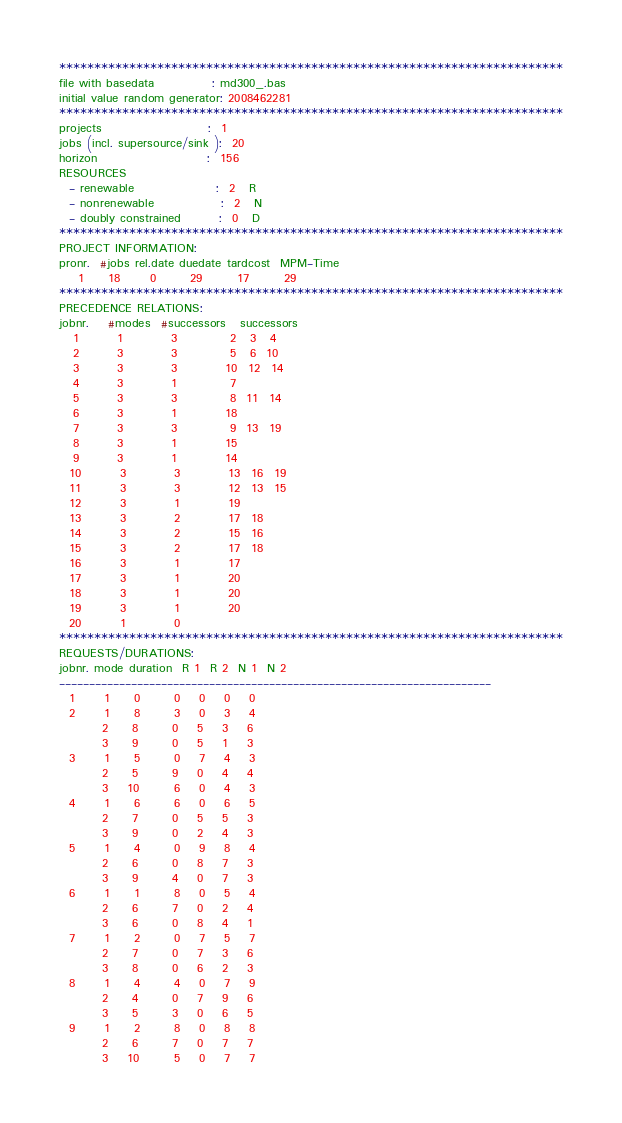Convert code to text. <code><loc_0><loc_0><loc_500><loc_500><_ObjectiveC_>************************************************************************
file with basedata            : md300_.bas
initial value random generator: 2008462281
************************************************************************
projects                      :  1
jobs (incl. supersource/sink ):  20
horizon                       :  156
RESOURCES
  - renewable                 :  2   R
  - nonrenewable              :  2   N
  - doubly constrained        :  0   D
************************************************************************
PROJECT INFORMATION:
pronr.  #jobs rel.date duedate tardcost  MPM-Time
    1     18      0       29       17       29
************************************************************************
PRECEDENCE RELATIONS:
jobnr.    #modes  #successors   successors
   1        1          3           2   3   4
   2        3          3           5   6  10
   3        3          3          10  12  14
   4        3          1           7
   5        3          3           8  11  14
   6        3          1          18
   7        3          3           9  13  19
   8        3          1          15
   9        3          1          14
  10        3          3          13  16  19
  11        3          3          12  13  15
  12        3          1          19
  13        3          2          17  18
  14        3          2          15  16
  15        3          2          17  18
  16        3          1          17
  17        3          1          20
  18        3          1          20
  19        3          1          20
  20        1          0        
************************************************************************
REQUESTS/DURATIONS:
jobnr. mode duration  R 1  R 2  N 1  N 2
------------------------------------------------------------------------
  1      1     0       0    0    0    0
  2      1     8       3    0    3    4
         2     8       0    5    3    6
         3     9       0    5    1    3
  3      1     5       0    7    4    3
         2     5       9    0    4    4
         3    10       6    0    4    3
  4      1     6       6    0    6    5
         2     7       0    5    5    3
         3     9       0    2    4    3
  5      1     4       0    9    8    4
         2     6       0    8    7    3
         3     9       4    0    7    3
  6      1     1       8    0    5    4
         2     6       7    0    2    4
         3     6       0    8    4    1
  7      1     2       0    7    5    7
         2     7       0    7    3    6
         3     8       0    6    2    3
  8      1     4       4    0    7    9
         2     4       0    7    9    6
         3     5       3    0    6    5
  9      1     2       8    0    8    8
         2     6       7    0    7    7
         3    10       5    0    7    7</code> 